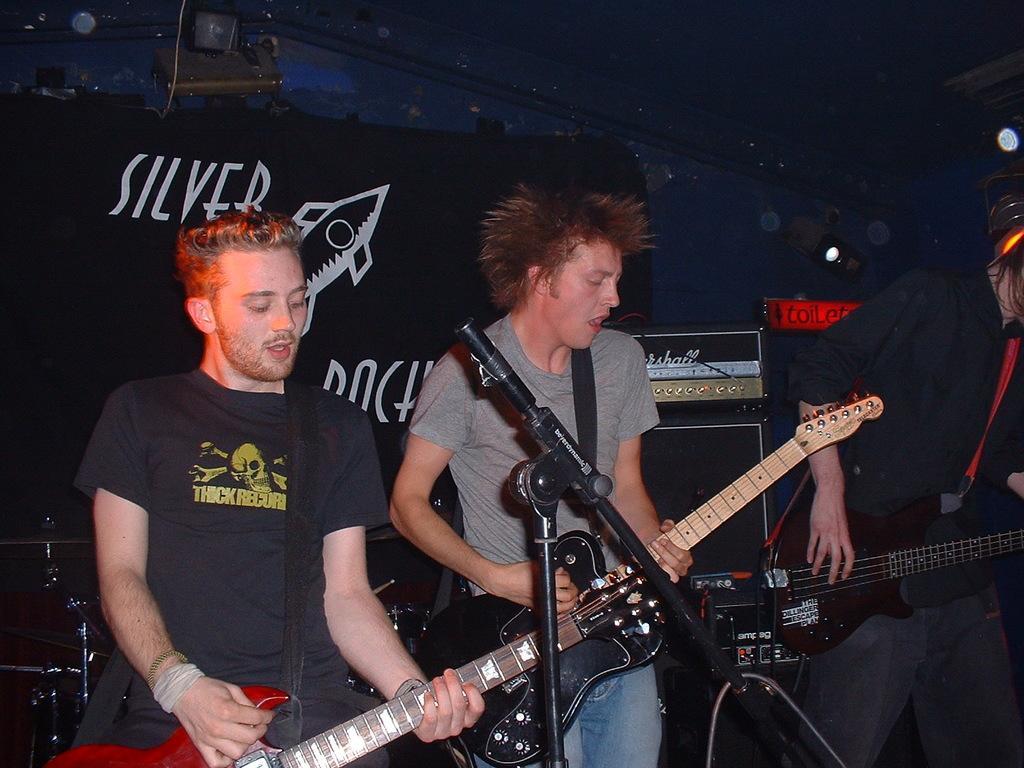How would you summarize this image in a sentence or two? In this image I can see few people are standing and holding guitars. I can also see a mic in front of them. 